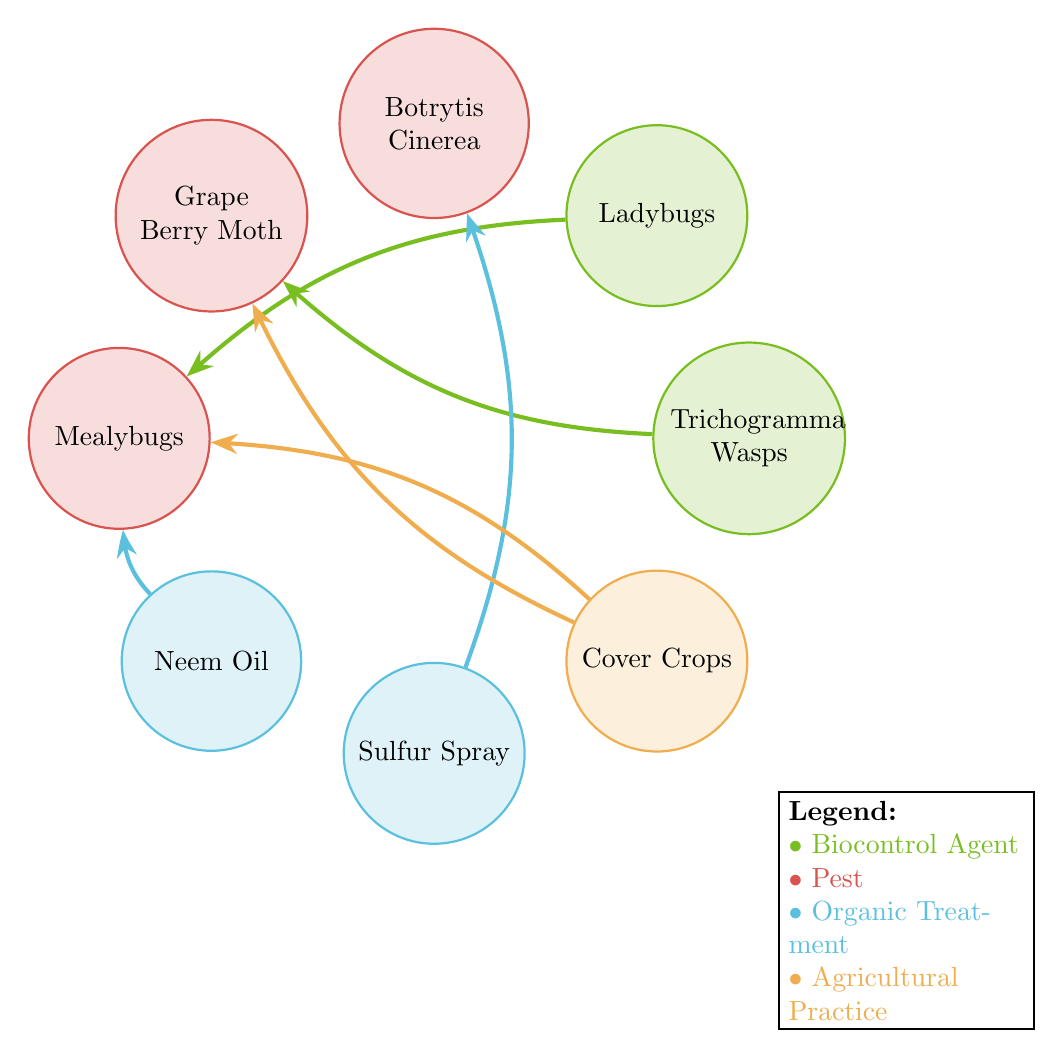What is the total number of nodes in the diagram? The diagram includes 8 nodes: Trichogramma Wasps, Ladybugs, Botrytis Cinerea, Grape Berry Moth, Mealybugs, Neem Oil, Sulfur Spray, and Cover Crops.
Answer: 8 Which organic treatment is linked to Mealybugs? The nodes show that both Neem Oil and Ladybugs have direct links to Mealybugs, indicating their role in controlling this pest.
Answer: Neem Oil and Ladybugs How many connections does Cover Crops have? Cover Crops is linked to two pests: Grape Berry Moth and Mealybugs, indicating its relevance in managing both of these pests.
Answer: 2 What type of agent controls Botrytis Cinerea? The diagram indicates that Sulfur Spray is the organic treatment linked to Botrytis Cinerea, highlighting its role in controlling this pest.
Answer: Organic Treatment Which biocontrol agent is associated with Grape Berry Moth? The diagram shows that Trichogramma Wasps and Cover Crops are both indicated to have relationships with Grape Berry Moth.
Answer: Trichogramma Wasps and Cover Crops Are there any biocontrol agents that target Mealybugs? Yes, the diagram shows that both Ladybugs and Neem Oil are associated with Mealybugs, indicating that they target this pest.
Answer: Yes, Ladybugs and Neem Oil Which pest is targeted by both a biocontrol agent and a treatment? Mealybugs are targeted by Ladybugs (biocontrol agent) and Neem Oil (organic treatment), as shown by the links in the diagram.
Answer: Mealybugs How many types of organic treatments are shown in the diagram? The diagram shows two types of organic treatments: Neem Oil and Sulfur Spray, highlighting different methods used in pest management.
Answer: 2 